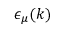Convert formula to latex. <formula><loc_0><loc_0><loc_500><loc_500>\epsilon _ { \mu } ( k )</formula> 